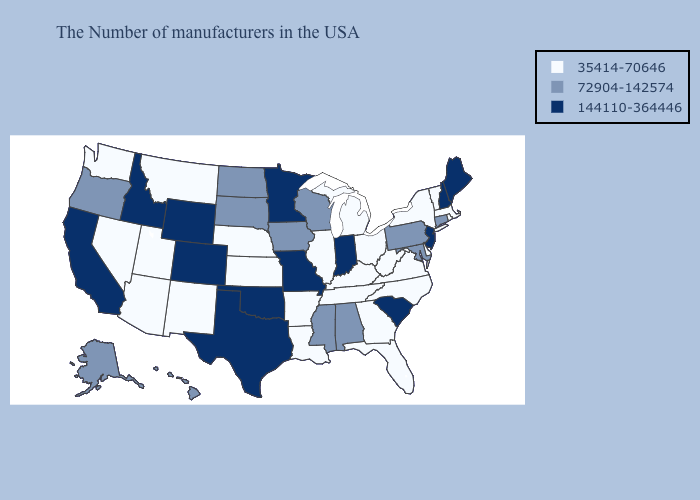What is the value of Maryland?
Give a very brief answer. 72904-142574. What is the highest value in states that border Colorado?
Be succinct. 144110-364446. What is the value of Wyoming?
Concise answer only. 144110-364446. Name the states that have a value in the range 144110-364446?
Write a very short answer. Maine, New Hampshire, New Jersey, South Carolina, Indiana, Missouri, Minnesota, Oklahoma, Texas, Wyoming, Colorado, Idaho, California. Name the states that have a value in the range 144110-364446?
Answer briefly. Maine, New Hampshire, New Jersey, South Carolina, Indiana, Missouri, Minnesota, Oklahoma, Texas, Wyoming, Colorado, Idaho, California. Among the states that border North Carolina , does South Carolina have the highest value?
Keep it brief. Yes. Does Kentucky have a lower value than Wyoming?
Give a very brief answer. Yes. Name the states that have a value in the range 35414-70646?
Concise answer only. Massachusetts, Rhode Island, Vermont, New York, Delaware, Virginia, North Carolina, West Virginia, Ohio, Florida, Georgia, Michigan, Kentucky, Tennessee, Illinois, Louisiana, Arkansas, Kansas, Nebraska, New Mexico, Utah, Montana, Arizona, Nevada, Washington. Name the states that have a value in the range 35414-70646?
Short answer required. Massachusetts, Rhode Island, Vermont, New York, Delaware, Virginia, North Carolina, West Virginia, Ohio, Florida, Georgia, Michigan, Kentucky, Tennessee, Illinois, Louisiana, Arkansas, Kansas, Nebraska, New Mexico, Utah, Montana, Arizona, Nevada, Washington. Does Michigan have a higher value than North Carolina?
Short answer required. No. What is the lowest value in states that border South Dakota?
Answer briefly. 35414-70646. What is the lowest value in the South?
Concise answer only. 35414-70646. What is the highest value in states that border Pennsylvania?
Keep it brief. 144110-364446. What is the value of New Jersey?
Be succinct. 144110-364446. Name the states that have a value in the range 35414-70646?
Short answer required. Massachusetts, Rhode Island, Vermont, New York, Delaware, Virginia, North Carolina, West Virginia, Ohio, Florida, Georgia, Michigan, Kentucky, Tennessee, Illinois, Louisiana, Arkansas, Kansas, Nebraska, New Mexico, Utah, Montana, Arizona, Nevada, Washington. 